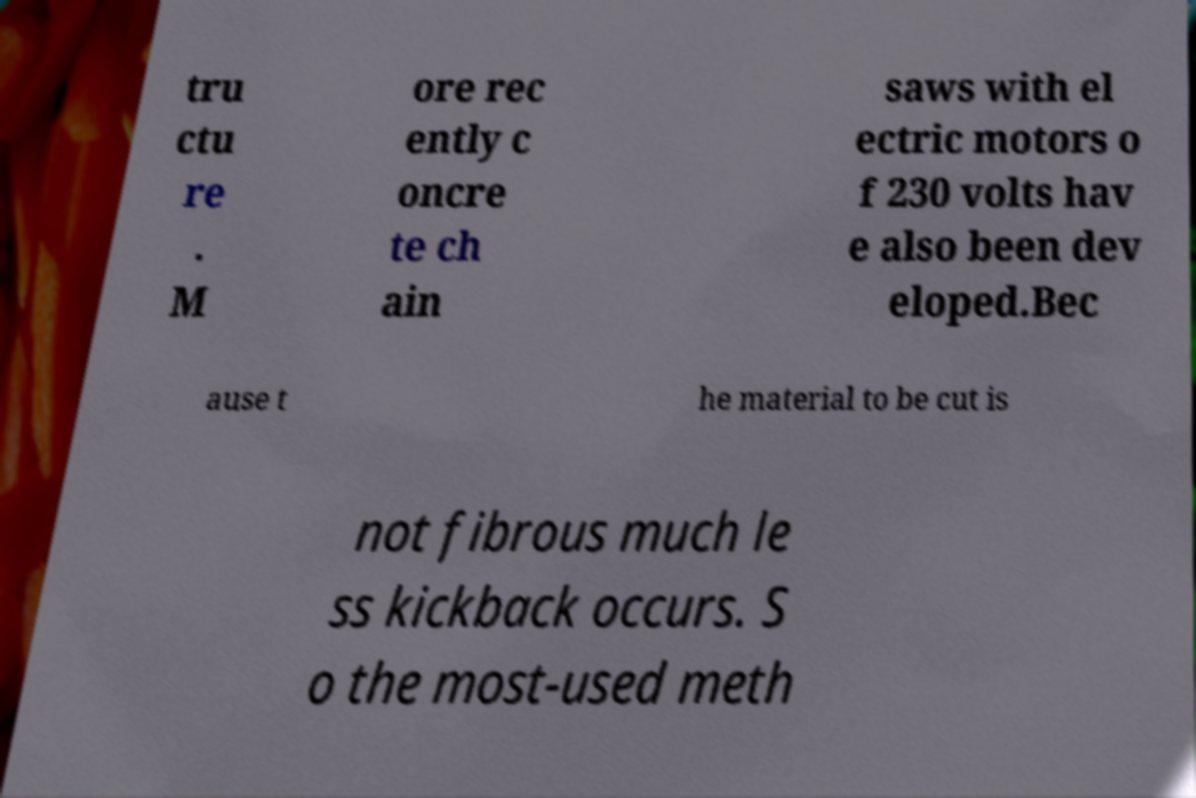Can you read and provide the text displayed in the image?This photo seems to have some interesting text. Can you extract and type it out for me? tru ctu re . M ore rec ently c oncre te ch ain saws with el ectric motors o f 230 volts hav e also been dev eloped.Bec ause t he material to be cut is not fibrous much le ss kickback occurs. S o the most-used meth 